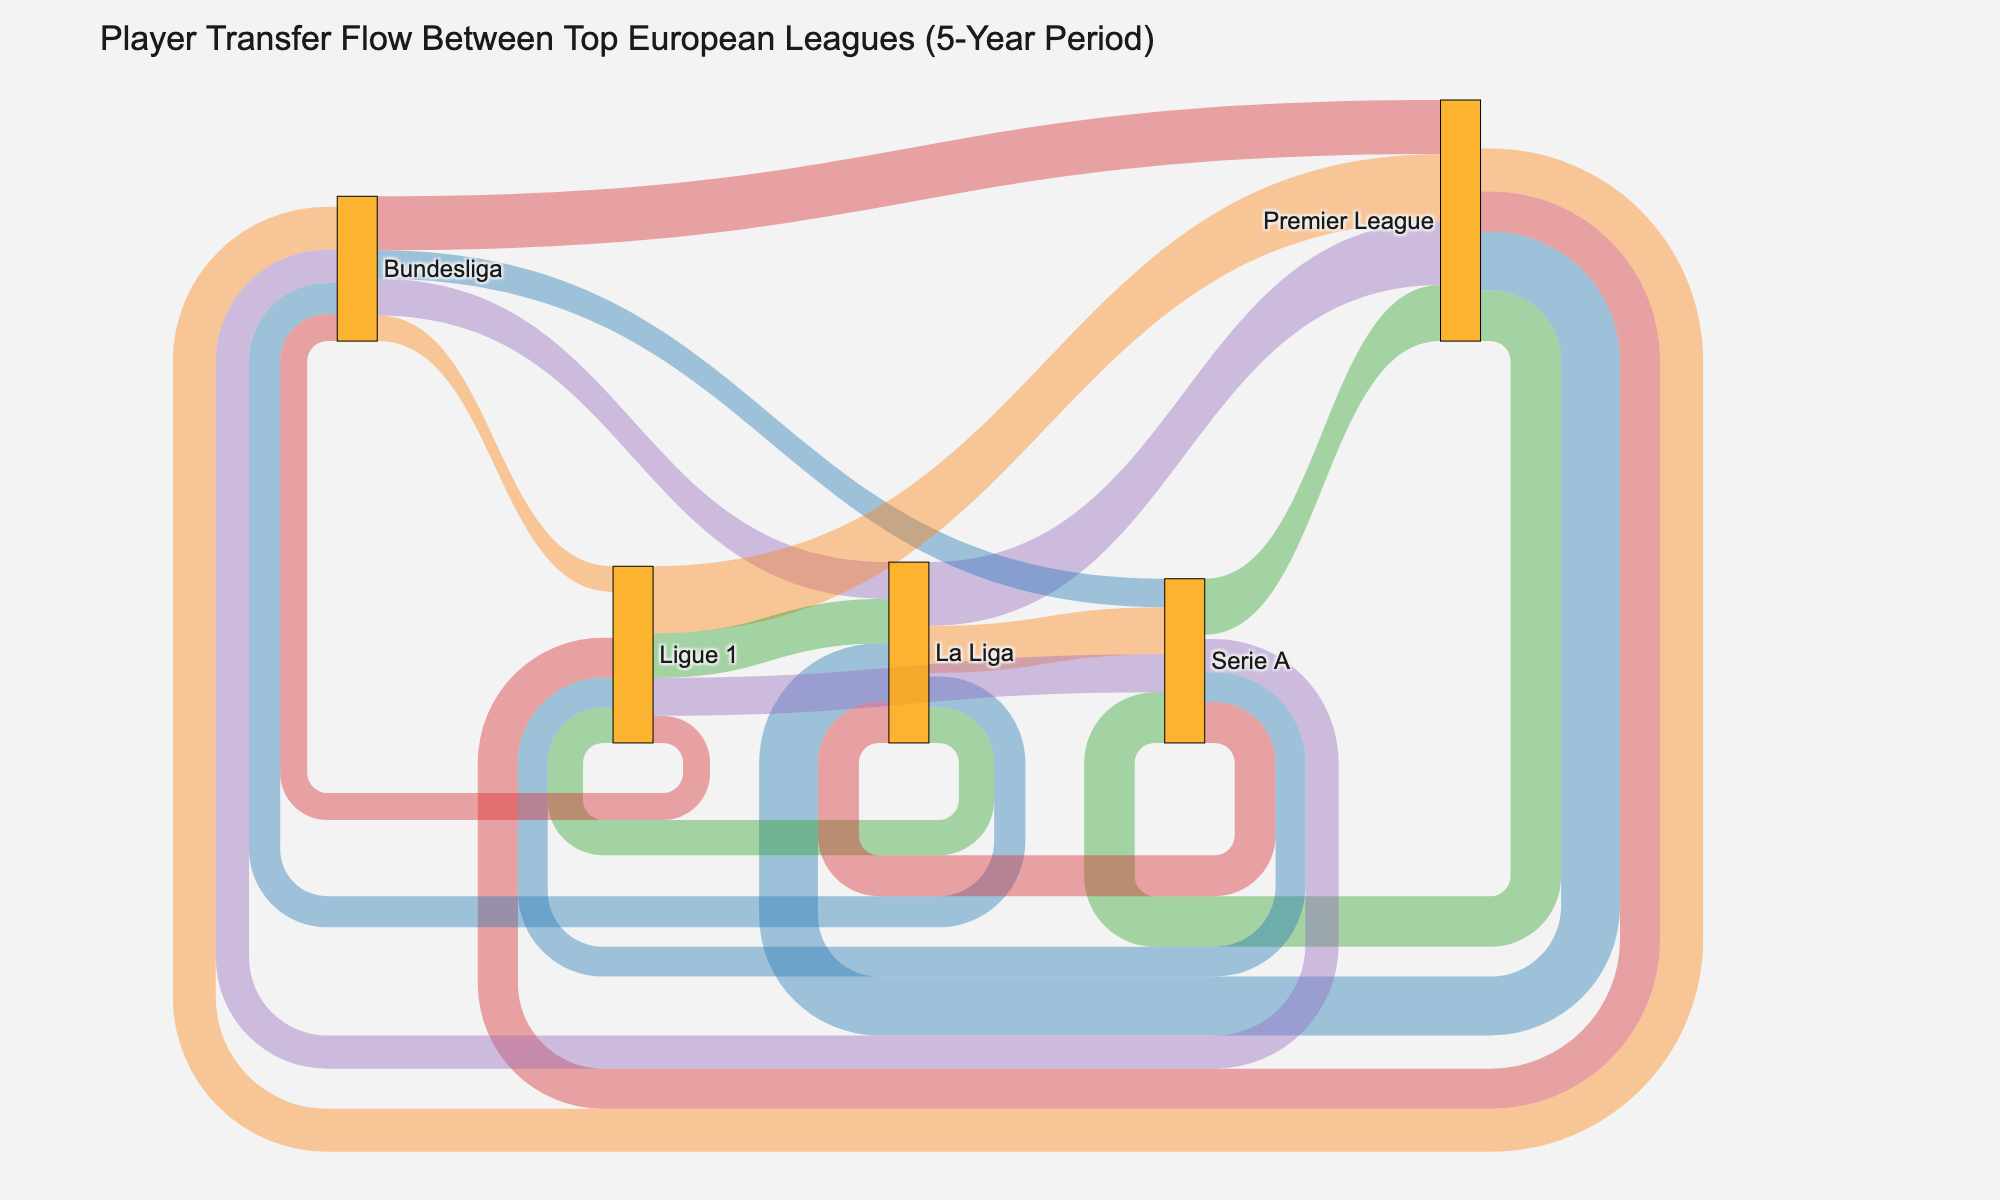What is the title of the Sankey diagram? The title of the Sankey diagram is usually displayed prominently at the top of the figure. It provides information about what the diagram represents.
Answer: Player Transfer Flow Between Top European Leagues (5-Year Period) Which league has the highest number of player transfers to the Premier League? Look at the "source" nodes and trace which node has the thickest connection leading to the "target" node labeled as Premier League. The thickness of the connection indicates the volume of transfers.
Answer: Ligue 1 How many total player transfers occurred from the Premier League to other leagues? To find the total number of player transfers from the Premier League, sum up all the "value" entries where the source is Premier League.
Answer: 278 Compare the player transfers from Serie A to the Premier League and from Serie A to La Liga. Which direction has more transfers? Examine the connections emanating from Serie A and compare the thicknesses or values of the transfers going to the Premier League and La Liga.
Answer: Premier League What is the sum of player transfers between La Liga and the Premier League (in both directions)? Sum the values of player transfers from La Liga to the Premier League and from the Premier League to La Liga by adding 92 and 85.
Answer: 177 Which league has transferred fewer players to Ligue 1 compared to the other leagues? Identify the nodes connecting to Ligue 1, then compare the values of the transfers from other leagues to Ligue 1. The smallest value indicates the fewest transfers.
Answer: Bundesliga What’s the average number of player transfers from Ligue 1 to all other leagues? Identify all the values where the source is Ligue 1 (97, 64, 39, 55) and calculate their average: (97 + 64 + 39 + 55) / 4.
Answer: 63.75 How many total player transfers have occurred between Bundesliga and other leagues (including both incoming and outgoing)? Sum all the values where the source or target is Bundesliga: 62 + 45 + 78 + 53 + 41 + 37 + 48 + 39.
Answer: 403 Which league has the second-highest outgoing transfers to other leagues? Calculate the total outgoing transfers for each league and determine which one is second highest. La Liga has (92+45+68+51) = 256, Bundesliga (62+78+53+41) = 234, Ligue 1 (97+64+39+55) = 255, Serie A (81+59+48+43) = 231. The second-highest is Ligue 1.
Answer: Ligue 1 What color are the nodes in the Sankey diagram? The nodes' colors are described in the data or can be observed directly from the visual, which in this case is given as "rgba(255, 165, 0, 0.8)," a type of orange.
Answer: Orange 